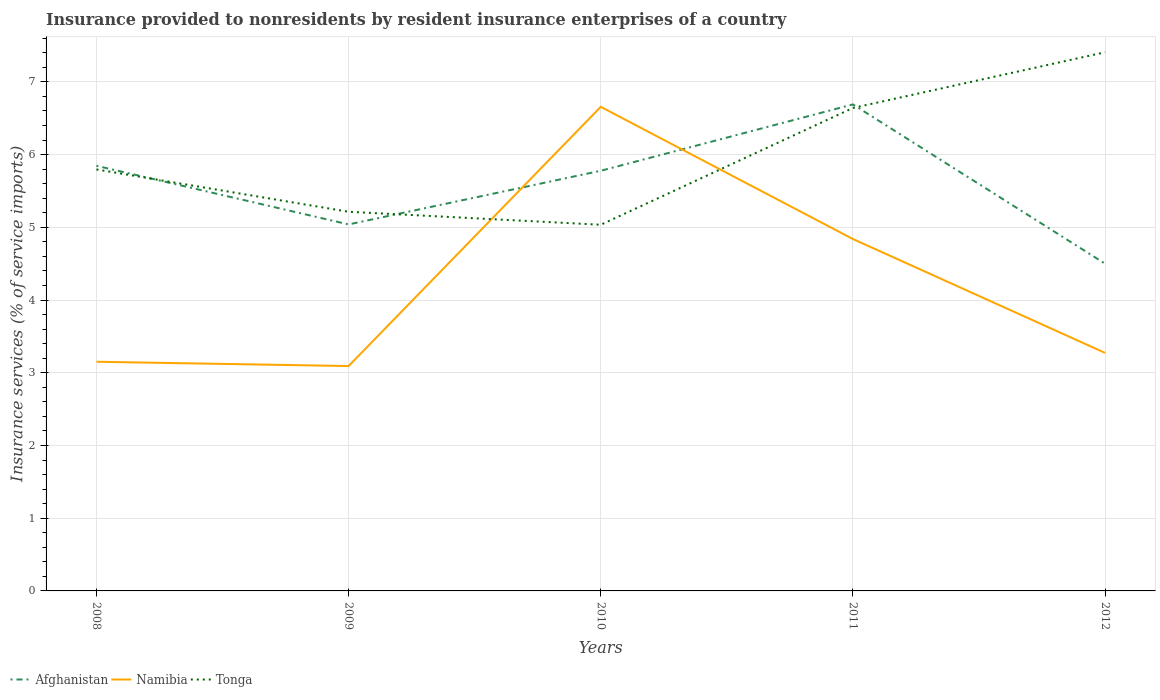How many different coloured lines are there?
Offer a very short reply. 3. Does the line corresponding to Namibia intersect with the line corresponding to Afghanistan?
Ensure brevity in your answer.  Yes. Is the number of lines equal to the number of legend labels?
Provide a short and direct response. Yes. Across all years, what is the maximum insurance provided to nonresidents in Afghanistan?
Provide a short and direct response. 4.5. What is the total insurance provided to nonresidents in Namibia in the graph?
Your answer should be very brief. -0.18. What is the difference between the highest and the second highest insurance provided to nonresidents in Afghanistan?
Offer a terse response. 2.19. Is the insurance provided to nonresidents in Tonga strictly greater than the insurance provided to nonresidents in Namibia over the years?
Keep it short and to the point. No. Are the values on the major ticks of Y-axis written in scientific E-notation?
Give a very brief answer. No. Does the graph contain any zero values?
Keep it short and to the point. No. Does the graph contain grids?
Your answer should be compact. Yes. Where does the legend appear in the graph?
Make the answer very short. Bottom left. What is the title of the graph?
Provide a succinct answer. Insurance provided to nonresidents by resident insurance enterprises of a country. What is the label or title of the Y-axis?
Your answer should be compact. Insurance services (% of service imports). What is the Insurance services (% of service imports) in Afghanistan in 2008?
Offer a terse response. 5.85. What is the Insurance services (% of service imports) of Namibia in 2008?
Your answer should be very brief. 3.15. What is the Insurance services (% of service imports) in Tonga in 2008?
Ensure brevity in your answer.  5.8. What is the Insurance services (% of service imports) of Afghanistan in 2009?
Give a very brief answer. 5.04. What is the Insurance services (% of service imports) of Namibia in 2009?
Provide a short and direct response. 3.09. What is the Insurance services (% of service imports) in Tonga in 2009?
Your response must be concise. 5.21. What is the Insurance services (% of service imports) of Afghanistan in 2010?
Your answer should be very brief. 5.78. What is the Insurance services (% of service imports) in Namibia in 2010?
Offer a very short reply. 6.66. What is the Insurance services (% of service imports) of Tonga in 2010?
Keep it short and to the point. 5.04. What is the Insurance services (% of service imports) in Afghanistan in 2011?
Offer a terse response. 6.69. What is the Insurance services (% of service imports) of Namibia in 2011?
Ensure brevity in your answer.  4.84. What is the Insurance services (% of service imports) in Tonga in 2011?
Give a very brief answer. 6.64. What is the Insurance services (% of service imports) of Afghanistan in 2012?
Your response must be concise. 4.5. What is the Insurance services (% of service imports) of Namibia in 2012?
Your answer should be very brief. 3.27. What is the Insurance services (% of service imports) of Tonga in 2012?
Keep it short and to the point. 7.41. Across all years, what is the maximum Insurance services (% of service imports) in Afghanistan?
Give a very brief answer. 6.69. Across all years, what is the maximum Insurance services (% of service imports) in Namibia?
Offer a very short reply. 6.66. Across all years, what is the maximum Insurance services (% of service imports) of Tonga?
Provide a short and direct response. 7.41. Across all years, what is the minimum Insurance services (% of service imports) in Afghanistan?
Offer a very short reply. 4.5. Across all years, what is the minimum Insurance services (% of service imports) in Namibia?
Give a very brief answer. 3.09. Across all years, what is the minimum Insurance services (% of service imports) in Tonga?
Offer a very short reply. 5.04. What is the total Insurance services (% of service imports) in Afghanistan in the graph?
Offer a terse response. 27.85. What is the total Insurance services (% of service imports) of Namibia in the graph?
Offer a terse response. 21.01. What is the total Insurance services (% of service imports) of Tonga in the graph?
Offer a very short reply. 30.09. What is the difference between the Insurance services (% of service imports) of Afghanistan in 2008 and that in 2009?
Offer a terse response. 0.81. What is the difference between the Insurance services (% of service imports) of Namibia in 2008 and that in 2009?
Make the answer very short. 0.06. What is the difference between the Insurance services (% of service imports) of Tonga in 2008 and that in 2009?
Offer a very short reply. 0.58. What is the difference between the Insurance services (% of service imports) in Afghanistan in 2008 and that in 2010?
Keep it short and to the point. 0.07. What is the difference between the Insurance services (% of service imports) in Namibia in 2008 and that in 2010?
Provide a short and direct response. -3.51. What is the difference between the Insurance services (% of service imports) of Tonga in 2008 and that in 2010?
Offer a very short reply. 0.76. What is the difference between the Insurance services (% of service imports) of Afghanistan in 2008 and that in 2011?
Keep it short and to the point. -0.84. What is the difference between the Insurance services (% of service imports) of Namibia in 2008 and that in 2011?
Provide a short and direct response. -1.69. What is the difference between the Insurance services (% of service imports) in Tonga in 2008 and that in 2011?
Your response must be concise. -0.85. What is the difference between the Insurance services (% of service imports) of Afghanistan in 2008 and that in 2012?
Your answer should be very brief. 1.35. What is the difference between the Insurance services (% of service imports) in Namibia in 2008 and that in 2012?
Provide a short and direct response. -0.12. What is the difference between the Insurance services (% of service imports) in Tonga in 2008 and that in 2012?
Your answer should be very brief. -1.61. What is the difference between the Insurance services (% of service imports) of Afghanistan in 2009 and that in 2010?
Offer a terse response. -0.74. What is the difference between the Insurance services (% of service imports) in Namibia in 2009 and that in 2010?
Your response must be concise. -3.56. What is the difference between the Insurance services (% of service imports) in Tonga in 2009 and that in 2010?
Give a very brief answer. 0.18. What is the difference between the Insurance services (% of service imports) in Afghanistan in 2009 and that in 2011?
Offer a very short reply. -1.65. What is the difference between the Insurance services (% of service imports) in Namibia in 2009 and that in 2011?
Keep it short and to the point. -1.75. What is the difference between the Insurance services (% of service imports) in Tonga in 2009 and that in 2011?
Offer a very short reply. -1.43. What is the difference between the Insurance services (% of service imports) in Afghanistan in 2009 and that in 2012?
Provide a short and direct response. 0.54. What is the difference between the Insurance services (% of service imports) of Namibia in 2009 and that in 2012?
Offer a very short reply. -0.18. What is the difference between the Insurance services (% of service imports) in Tonga in 2009 and that in 2012?
Make the answer very short. -2.19. What is the difference between the Insurance services (% of service imports) in Afghanistan in 2010 and that in 2011?
Provide a succinct answer. -0.91. What is the difference between the Insurance services (% of service imports) of Namibia in 2010 and that in 2011?
Keep it short and to the point. 1.82. What is the difference between the Insurance services (% of service imports) in Tonga in 2010 and that in 2011?
Offer a very short reply. -1.61. What is the difference between the Insurance services (% of service imports) of Afghanistan in 2010 and that in 2012?
Provide a short and direct response. 1.28. What is the difference between the Insurance services (% of service imports) of Namibia in 2010 and that in 2012?
Ensure brevity in your answer.  3.38. What is the difference between the Insurance services (% of service imports) in Tonga in 2010 and that in 2012?
Offer a very short reply. -2.37. What is the difference between the Insurance services (% of service imports) in Afghanistan in 2011 and that in 2012?
Your answer should be compact. 2.19. What is the difference between the Insurance services (% of service imports) of Namibia in 2011 and that in 2012?
Ensure brevity in your answer.  1.57. What is the difference between the Insurance services (% of service imports) in Tonga in 2011 and that in 2012?
Ensure brevity in your answer.  -0.77. What is the difference between the Insurance services (% of service imports) in Afghanistan in 2008 and the Insurance services (% of service imports) in Namibia in 2009?
Offer a terse response. 2.75. What is the difference between the Insurance services (% of service imports) in Afghanistan in 2008 and the Insurance services (% of service imports) in Tonga in 2009?
Make the answer very short. 0.63. What is the difference between the Insurance services (% of service imports) of Namibia in 2008 and the Insurance services (% of service imports) of Tonga in 2009?
Provide a succinct answer. -2.06. What is the difference between the Insurance services (% of service imports) of Afghanistan in 2008 and the Insurance services (% of service imports) of Namibia in 2010?
Offer a terse response. -0.81. What is the difference between the Insurance services (% of service imports) in Afghanistan in 2008 and the Insurance services (% of service imports) in Tonga in 2010?
Ensure brevity in your answer.  0.81. What is the difference between the Insurance services (% of service imports) in Namibia in 2008 and the Insurance services (% of service imports) in Tonga in 2010?
Offer a very short reply. -1.88. What is the difference between the Insurance services (% of service imports) of Afghanistan in 2008 and the Insurance services (% of service imports) of Namibia in 2011?
Keep it short and to the point. 1.01. What is the difference between the Insurance services (% of service imports) of Afghanistan in 2008 and the Insurance services (% of service imports) of Tonga in 2011?
Provide a succinct answer. -0.8. What is the difference between the Insurance services (% of service imports) in Namibia in 2008 and the Insurance services (% of service imports) in Tonga in 2011?
Ensure brevity in your answer.  -3.49. What is the difference between the Insurance services (% of service imports) in Afghanistan in 2008 and the Insurance services (% of service imports) in Namibia in 2012?
Your response must be concise. 2.57. What is the difference between the Insurance services (% of service imports) in Afghanistan in 2008 and the Insurance services (% of service imports) in Tonga in 2012?
Give a very brief answer. -1.56. What is the difference between the Insurance services (% of service imports) in Namibia in 2008 and the Insurance services (% of service imports) in Tonga in 2012?
Offer a terse response. -4.26. What is the difference between the Insurance services (% of service imports) in Afghanistan in 2009 and the Insurance services (% of service imports) in Namibia in 2010?
Provide a short and direct response. -1.62. What is the difference between the Insurance services (% of service imports) of Afghanistan in 2009 and the Insurance services (% of service imports) of Tonga in 2010?
Your answer should be very brief. 0. What is the difference between the Insurance services (% of service imports) in Namibia in 2009 and the Insurance services (% of service imports) in Tonga in 2010?
Provide a short and direct response. -1.94. What is the difference between the Insurance services (% of service imports) in Afghanistan in 2009 and the Insurance services (% of service imports) in Namibia in 2011?
Your response must be concise. 0.2. What is the difference between the Insurance services (% of service imports) of Afghanistan in 2009 and the Insurance services (% of service imports) of Tonga in 2011?
Give a very brief answer. -1.6. What is the difference between the Insurance services (% of service imports) in Namibia in 2009 and the Insurance services (% of service imports) in Tonga in 2011?
Ensure brevity in your answer.  -3.55. What is the difference between the Insurance services (% of service imports) of Afghanistan in 2009 and the Insurance services (% of service imports) of Namibia in 2012?
Offer a terse response. 1.77. What is the difference between the Insurance services (% of service imports) of Afghanistan in 2009 and the Insurance services (% of service imports) of Tonga in 2012?
Make the answer very short. -2.37. What is the difference between the Insurance services (% of service imports) in Namibia in 2009 and the Insurance services (% of service imports) in Tonga in 2012?
Give a very brief answer. -4.31. What is the difference between the Insurance services (% of service imports) of Afghanistan in 2010 and the Insurance services (% of service imports) of Namibia in 2011?
Give a very brief answer. 0.94. What is the difference between the Insurance services (% of service imports) in Afghanistan in 2010 and the Insurance services (% of service imports) in Tonga in 2011?
Your answer should be compact. -0.86. What is the difference between the Insurance services (% of service imports) in Namibia in 2010 and the Insurance services (% of service imports) in Tonga in 2011?
Your answer should be very brief. 0.02. What is the difference between the Insurance services (% of service imports) of Afghanistan in 2010 and the Insurance services (% of service imports) of Namibia in 2012?
Provide a succinct answer. 2.5. What is the difference between the Insurance services (% of service imports) in Afghanistan in 2010 and the Insurance services (% of service imports) in Tonga in 2012?
Make the answer very short. -1.63. What is the difference between the Insurance services (% of service imports) of Namibia in 2010 and the Insurance services (% of service imports) of Tonga in 2012?
Your answer should be compact. -0.75. What is the difference between the Insurance services (% of service imports) of Afghanistan in 2011 and the Insurance services (% of service imports) of Namibia in 2012?
Provide a succinct answer. 3.42. What is the difference between the Insurance services (% of service imports) in Afghanistan in 2011 and the Insurance services (% of service imports) in Tonga in 2012?
Offer a very short reply. -0.72. What is the difference between the Insurance services (% of service imports) in Namibia in 2011 and the Insurance services (% of service imports) in Tonga in 2012?
Ensure brevity in your answer.  -2.57. What is the average Insurance services (% of service imports) in Afghanistan per year?
Give a very brief answer. 5.57. What is the average Insurance services (% of service imports) in Namibia per year?
Offer a very short reply. 4.2. What is the average Insurance services (% of service imports) in Tonga per year?
Your answer should be very brief. 6.02. In the year 2008, what is the difference between the Insurance services (% of service imports) of Afghanistan and Insurance services (% of service imports) of Namibia?
Provide a short and direct response. 2.69. In the year 2008, what is the difference between the Insurance services (% of service imports) of Afghanistan and Insurance services (% of service imports) of Tonga?
Give a very brief answer. 0.05. In the year 2008, what is the difference between the Insurance services (% of service imports) of Namibia and Insurance services (% of service imports) of Tonga?
Provide a short and direct response. -2.64. In the year 2009, what is the difference between the Insurance services (% of service imports) in Afghanistan and Insurance services (% of service imports) in Namibia?
Provide a short and direct response. 1.95. In the year 2009, what is the difference between the Insurance services (% of service imports) of Afghanistan and Insurance services (% of service imports) of Tonga?
Offer a very short reply. -0.17. In the year 2009, what is the difference between the Insurance services (% of service imports) in Namibia and Insurance services (% of service imports) in Tonga?
Offer a terse response. -2.12. In the year 2010, what is the difference between the Insurance services (% of service imports) in Afghanistan and Insurance services (% of service imports) in Namibia?
Offer a very short reply. -0.88. In the year 2010, what is the difference between the Insurance services (% of service imports) in Afghanistan and Insurance services (% of service imports) in Tonga?
Make the answer very short. 0.74. In the year 2010, what is the difference between the Insurance services (% of service imports) of Namibia and Insurance services (% of service imports) of Tonga?
Provide a short and direct response. 1.62. In the year 2011, what is the difference between the Insurance services (% of service imports) in Afghanistan and Insurance services (% of service imports) in Namibia?
Your answer should be compact. 1.85. In the year 2011, what is the difference between the Insurance services (% of service imports) in Afghanistan and Insurance services (% of service imports) in Tonga?
Give a very brief answer. 0.05. In the year 2011, what is the difference between the Insurance services (% of service imports) in Namibia and Insurance services (% of service imports) in Tonga?
Ensure brevity in your answer.  -1.8. In the year 2012, what is the difference between the Insurance services (% of service imports) in Afghanistan and Insurance services (% of service imports) in Namibia?
Provide a short and direct response. 1.23. In the year 2012, what is the difference between the Insurance services (% of service imports) of Afghanistan and Insurance services (% of service imports) of Tonga?
Provide a succinct answer. -2.91. In the year 2012, what is the difference between the Insurance services (% of service imports) of Namibia and Insurance services (% of service imports) of Tonga?
Give a very brief answer. -4.13. What is the ratio of the Insurance services (% of service imports) of Afghanistan in 2008 to that in 2009?
Your answer should be compact. 1.16. What is the ratio of the Insurance services (% of service imports) of Namibia in 2008 to that in 2009?
Make the answer very short. 1.02. What is the ratio of the Insurance services (% of service imports) of Tonga in 2008 to that in 2009?
Your answer should be very brief. 1.11. What is the ratio of the Insurance services (% of service imports) of Afghanistan in 2008 to that in 2010?
Give a very brief answer. 1.01. What is the ratio of the Insurance services (% of service imports) of Namibia in 2008 to that in 2010?
Ensure brevity in your answer.  0.47. What is the ratio of the Insurance services (% of service imports) of Tonga in 2008 to that in 2010?
Your answer should be very brief. 1.15. What is the ratio of the Insurance services (% of service imports) of Afghanistan in 2008 to that in 2011?
Make the answer very short. 0.87. What is the ratio of the Insurance services (% of service imports) of Namibia in 2008 to that in 2011?
Keep it short and to the point. 0.65. What is the ratio of the Insurance services (% of service imports) in Tonga in 2008 to that in 2011?
Ensure brevity in your answer.  0.87. What is the ratio of the Insurance services (% of service imports) of Afghanistan in 2008 to that in 2012?
Make the answer very short. 1.3. What is the ratio of the Insurance services (% of service imports) of Namibia in 2008 to that in 2012?
Your answer should be very brief. 0.96. What is the ratio of the Insurance services (% of service imports) in Tonga in 2008 to that in 2012?
Ensure brevity in your answer.  0.78. What is the ratio of the Insurance services (% of service imports) of Afghanistan in 2009 to that in 2010?
Offer a very short reply. 0.87. What is the ratio of the Insurance services (% of service imports) in Namibia in 2009 to that in 2010?
Provide a short and direct response. 0.46. What is the ratio of the Insurance services (% of service imports) in Tonga in 2009 to that in 2010?
Your answer should be compact. 1.04. What is the ratio of the Insurance services (% of service imports) in Afghanistan in 2009 to that in 2011?
Your answer should be compact. 0.75. What is the ratio of the Insurance services (% of service imports) in Namibia in 2009 to that in 2011?
Keep it short and to the point. 0.64. What is the ratio of the Insurance services (% of service imports) of Tonga in 2009 to that in 2011?
Your response must be concise. 0.79. What is the ratio of the Insurance services (% of service imports) in Afghanistan in 2009 to that in 2012?
Your response must be concise. 1.12. What is the ratio of the Insurance services (% of service imports) in Namibia in 2009 to that in 2012?
Offer a very short reply. 0.94. What is the ratio of the Insurance services (% of service imports) of Tonga in 2009 to that in 2012?
Offer a very short reply. 0.7. What is the ratio of the Insurance services (% of service imports) in Afghanistan in 2010 to that in 2011?
Offer a terse response. 0.86. What is the ratio of the Insurance services (% of service imports) of Namibia in 2010 to that in 2011?
Your answer should be compact. 1.38. What is the ratio of the Insurance services (% of service imports) in Tonga in 2010 to that in 2011?
Offer a very short reply. 0.76. What is the ratio of the Insurance services (% of service imports) in Afghanistan in 2010 to that in 2012?
Keep it short and to the point. 1.28. What is the ratio of the Insurance services (% of service imports) in Namibia in 2010 to that in 2012?
Ensure brevity in your answer.  2.03. What is the ratio of the Insurance services (% of service imports) in Tonga in 2010 to that in 2012?
Make the answer very short. 0.68. What is the ratio of the Insurance services (% of service imports) in Afghanistan in 2011 to that in 2012?
Offer a very short reply. 1.49. What is the ratio of the Insurance services (% of service imports) in Namibia in 2011 to that in 2012?
Your answer should be very brief. 1.48. What is the ratio of the Insurance services (% of service imports) in Tonga in 2011 to that in 2012?
Provide a short and direct response. 0.9. What is the difference between the highest and the second highest Insurance services (% of service imports) of Afghanistan?
Your answer should be compact. 0.84. What is the difference between the highest and the second highest Insurance services (% of service imports) of Namibia?
Your answer should be compact. 1.82. What is the difference between the highest and the second highest Insurance services (% of service imports) in Tonga?
Provide a short and direct response. 0.77. What is the difference between the highest and the lowest Insurance services (% of service imports) of Afghanistan?
Your response must be concise. 2.19. What is the difference between the highest and the lowest Insurance services (% of service imports) of Namibia?
Make the answer very short. 3.56. What is the difference between the highest and the lowest Insurance services (% of service imports) of Tonga?
Make the answer very short. 2.37. 